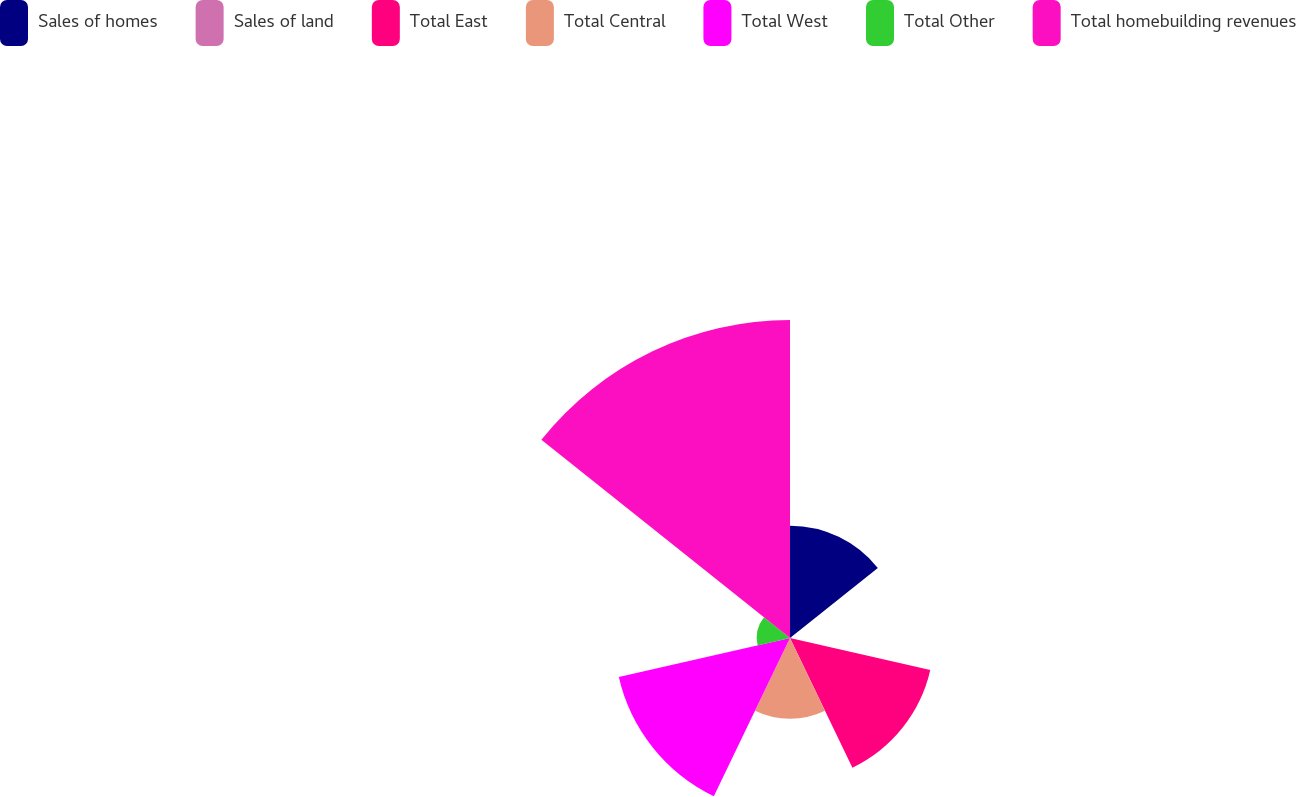Convert chart. <chart><loc_0><loc_0><loc_500><loc_500><pie_chart><fcel>Sales of homes<fcel>Sales of land<fcel>Total East<fcel>Total Central<fcel>Total West<fcel>Total Other<fcel>Total homebuilding revenues<nl><fcel>12.98%<fcel>0.19%<fcel>16.63%<fcel>9.32%<fcel>20.29%<fcel>3.84%<fcel>36.75%<nl></chart> 